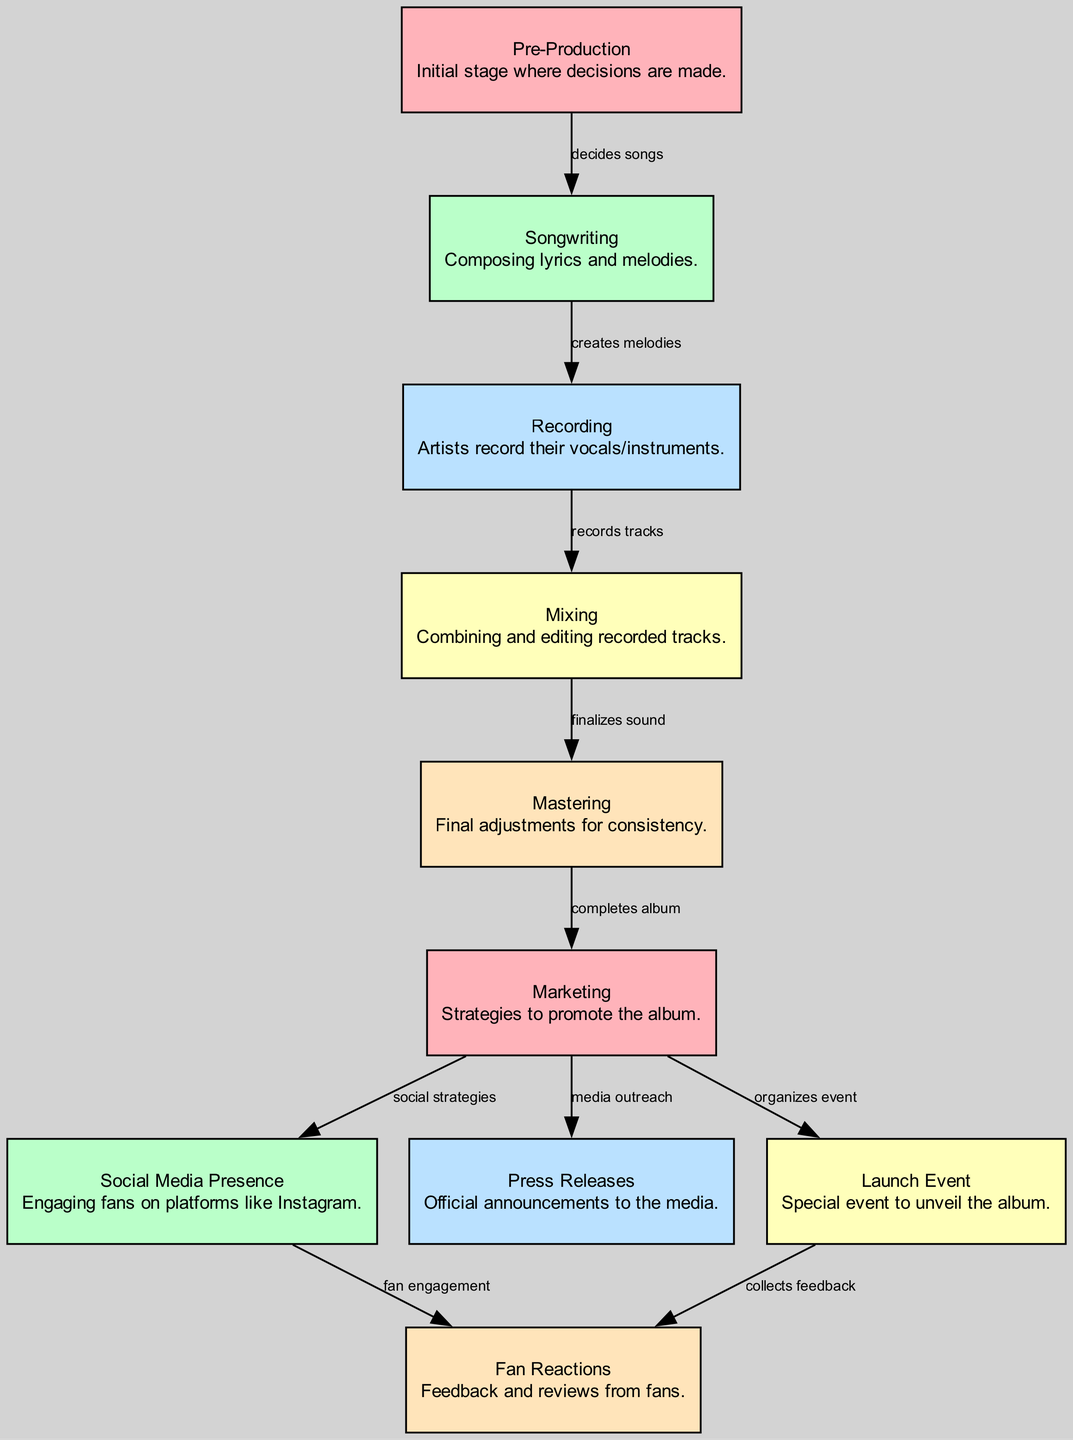What is the first stage in the music album launch? The diagram indicates that "Pre-Production" is the initial stage where decisions are made, marked as the first node.
Answer: Pre-Production How many nodes are present in the diagram? The diagram lists a total of 10 distinct nodes, representing various stages and elements of the music album launch process.
Answer: 10 What does the "Recording" stage lead to? From the diagram, the "Recording" stage (node 3) is followed by the "Mixing" stage (node 4), indicating the flow from recording tracks to combining them.
Answer: Mixing How does "Marketing" connect to "Fan Reactions"? The path from "Marketing" (node 6) to "Fan Reactions" (node 10) involves the "Launch Event" (node 9), which collects fan feedback, showing a relationship where the marketing efforts ultimately engage fans.
Answer: Launch Event How many edges connect the "Mastering" stage to subsequent stages? The diagram shows that there is one direct edge connecting the "Mastering" stage (node 5) to "Marketing" (node 6), indicating one path forward from mastering to marketing the completed album.
Answer: 1 What is the relationship between "Social Media Presence" and "Fan Reactions"? The relationship is that "Social Media Presence" (node 7) engages fans, leading to "Fan Reactions" (node 10), demonstrating an interaction where social strategies influence fan feedback.
Answer: Fan engagement Which stage directly precedes "Mixing"? According to the diagram, "Recording" (node 3) is the stage that comes immediately before "Mixing" (node 4), as indicated by the directed edge connecting them.
Answer: Recording What is the purpose of "Press Releases"? The diagram describes "Press Releases" (node 8) as part of the "Marketing" strategy, specifically for "media outreach," indicating their role in announcing album details to the public and press.
Answer: Media outreach 